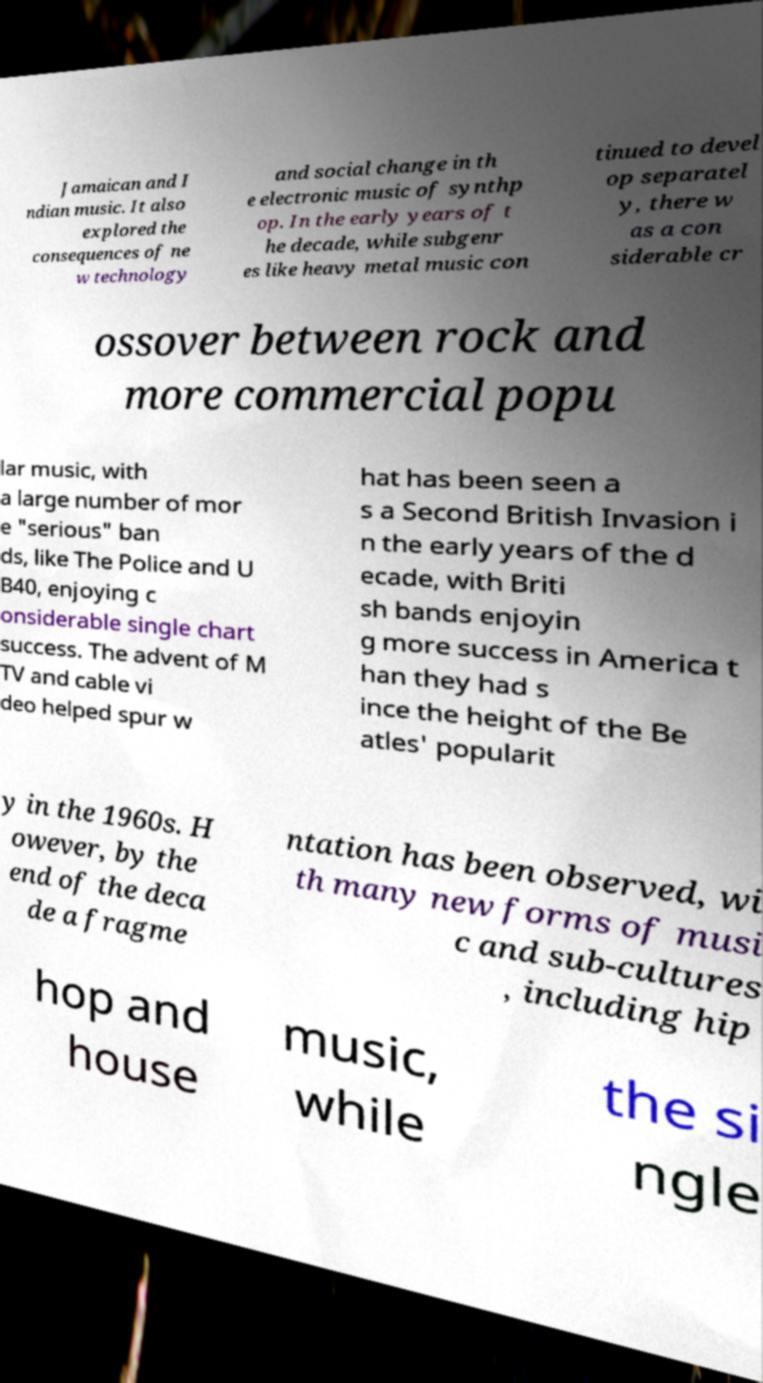What messages or text are displayed in this image? I need them in a readable, typed format. Jamaican and I ndian music. It also explored the consequences of ne w technology and social change in th e electronic music of synthp op. In the early years of t he decade, while subgenr es like heavy metal music con tinued to devel op separatel y, there w as a con siderable cr ossover between rock and more commercial popu lar music, with a large number of mor e "serious" ban ds, like The Police and U B40, enjoying c onsiderable single chart success. The advent of M TV and cable vi deo helped spur w hat has been seen a s a Second British Invasion i n the early years of the d ecade, with Briti sh bands enjoyin g more success in America t han they had s ince the height of the Be atles' popularit y in the 1960s. H owever, by the end of the deca de a fragme ntation has been observed, wi th many new forms of musi c and sub-cultures , including hip hop and house music, while the si ngle 